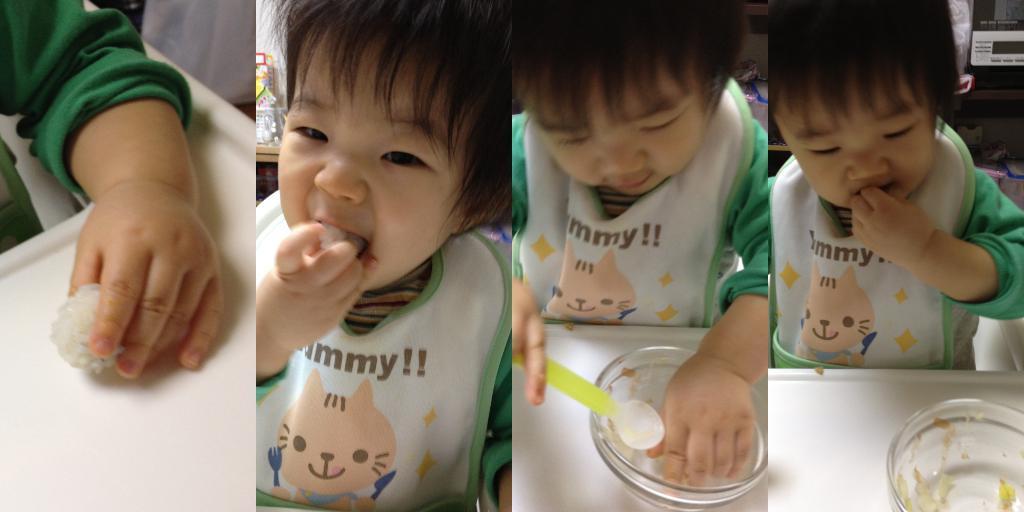In one or two sentences, can you explain what this image depicts? In this image we can see four pictures. In the first picture we can see a child hand holding food item and here we can see a child is eating food item, here we can see the ball placed on the white color surface and here we can see the child is holding the spoon. 